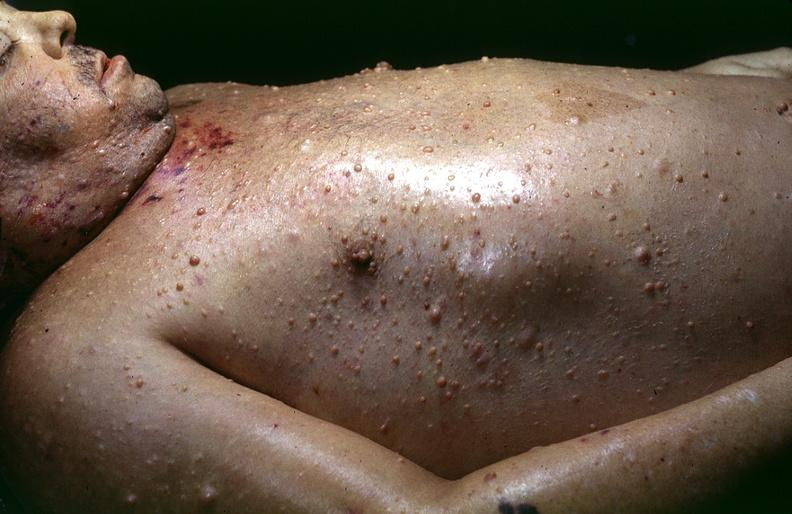where is this?
Answer the question using a single word or phrase. Skin 